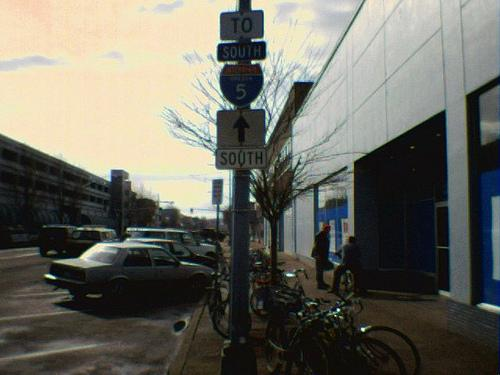Why are the bikes on the poles? Please explain your reasoning. keep safe. The bikes are temporarily attached to racks next to the poles, or to the poles themselves.  each bike is attached independently of the others with a chain and lock, and a lock reduces risk of theft of the item that is locked up. 